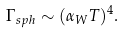Convert formula to latex. <formula><loc_0><loc_0><loc_500><loc_500>\Gamma _ { s p h } \sim ( \alpha _ { W } T ) ^ { 4 } .</formula> 